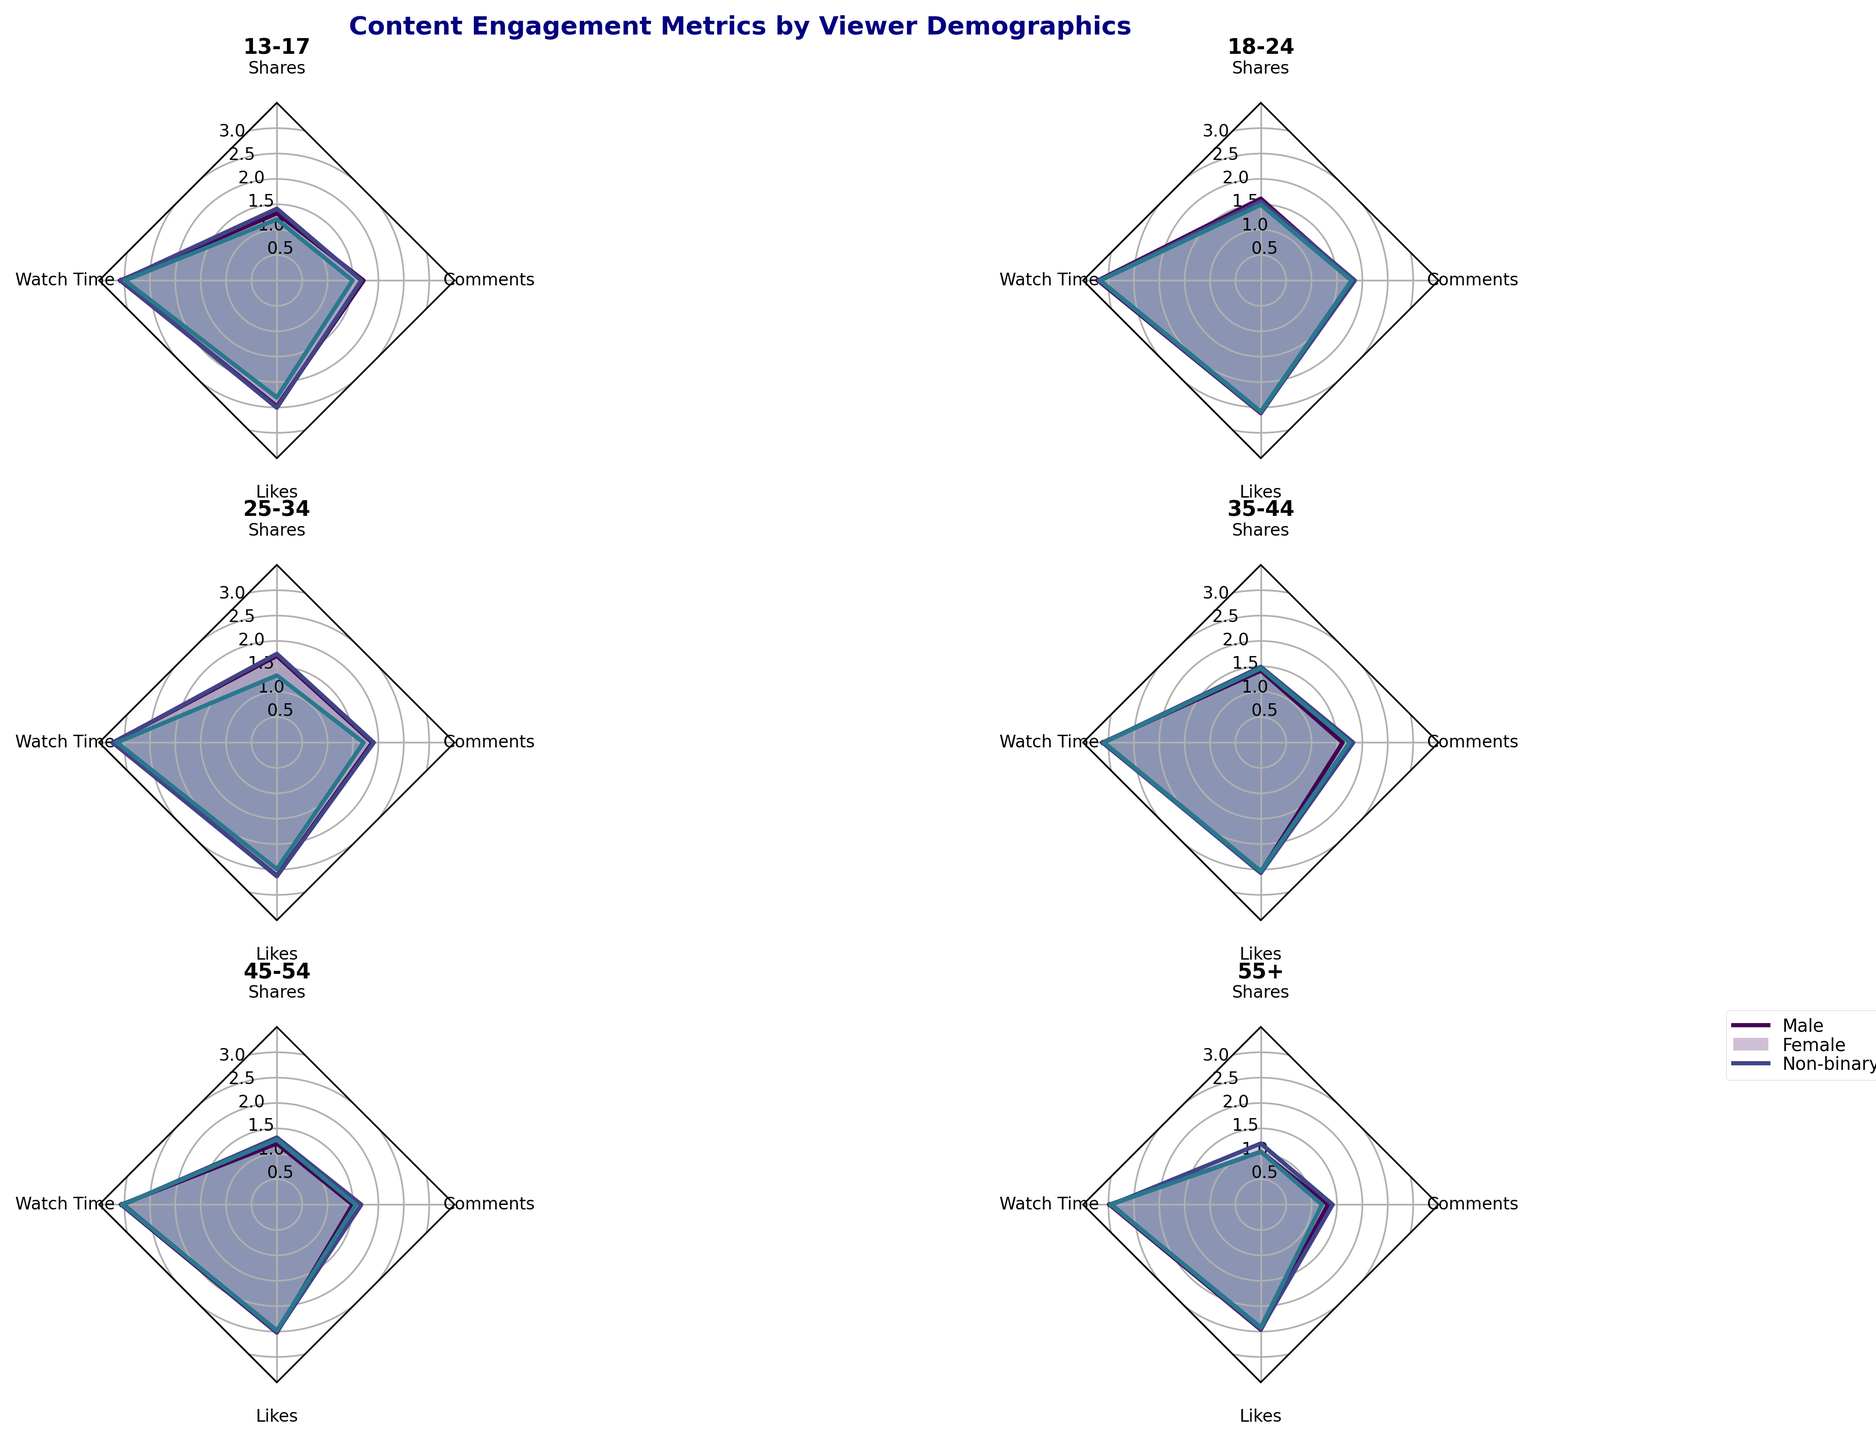What is the title of the figure? The title is usually placed at the top center of the figure. In this case, the title is "Content Engagement Metrics by Viewer Demographics", as it is stated in the code.
Answer: Content Engagement Metrics by Viewer Demographics How many subplots are there in the figure? The figure contains six subplots arranged in a 3x2 grid, as specified by the `nrows=3` and `ncols=2` parameters in the code.
Answer: Six Which age group has the highest watch time overall? In each subplot, the watcher time is one of the metrics displayed. By visually inspecting the plots for the highest watch time, the subplot for the age group "Adults, 25-34" shows the highest values.
Answer: Adults, 25-34 What is the range of the radial grid lines in the figure? The radial grid lines range from 0.5 to 3.5 with increments of 0.5, as set by the `ax.set_rgrids([0.5, 1, 1.5, 2, 2.5, 3])` and `ax.set_ylim(0, 3.5)` lines in the code.
Answer: 0.5 to 3.5 Which gender typically shows higher engagement (likes, comments, shares) in the "Teens" category? By comparing the filled areas for each gender in the "Teens" subplot, females overall appear to have slightly higher engagement in metrics (likes, comments, shares).
Answer: Female Does "Young Adults, 18-24" have a more even distribution of engagement metrics compared to "Seniors, 55+"? For this, look at the shape of the radar plots for both subgroups. Young Adults' plots tend to be more evenly distributed around the radial grid, whereas Seniors’ engagement metrics plots show more uneven areas.
Answer: Yes What metric does the "Non-binary" category seem to have lower values in across all age groups? Inspect the radar plots for each age group and note the Non-binary category's line. Generally, "Comments" and "Shares" have lower values compared to "Watch Time" and "Likes".
Answer: Comments and Shares For the "Adults, 35-44" age group, which metric has the highest variation among different gender groups? The radar chart for "Adults, 35-44" shows various distances from the center for each metric. The highest variation can be seen in "Likes", where there is the widest spread from lowest to highest value.
Answer: Likes How do the engagement patterns differ between "Mobile" and "Smart TV" devices for the "Adults, 45-54" age group? Check the plots for "Adults, 45-54" using different devices. Those using Mobile seem to show higher engagement metrics compared to those using Smart TV, as illustrated by the overall larger areas in the radar chart.
Answer: Mobile shows higher engagement What is the overall trend in engagement metrics from "Teens" to "Seniors" age groups? Looking across the subplots from "Teens" to "Seniors", there's a general decline in the total area covered on the radar charts, indicating decreasing engagement as age increases.
Answer: Decreasing engagement 